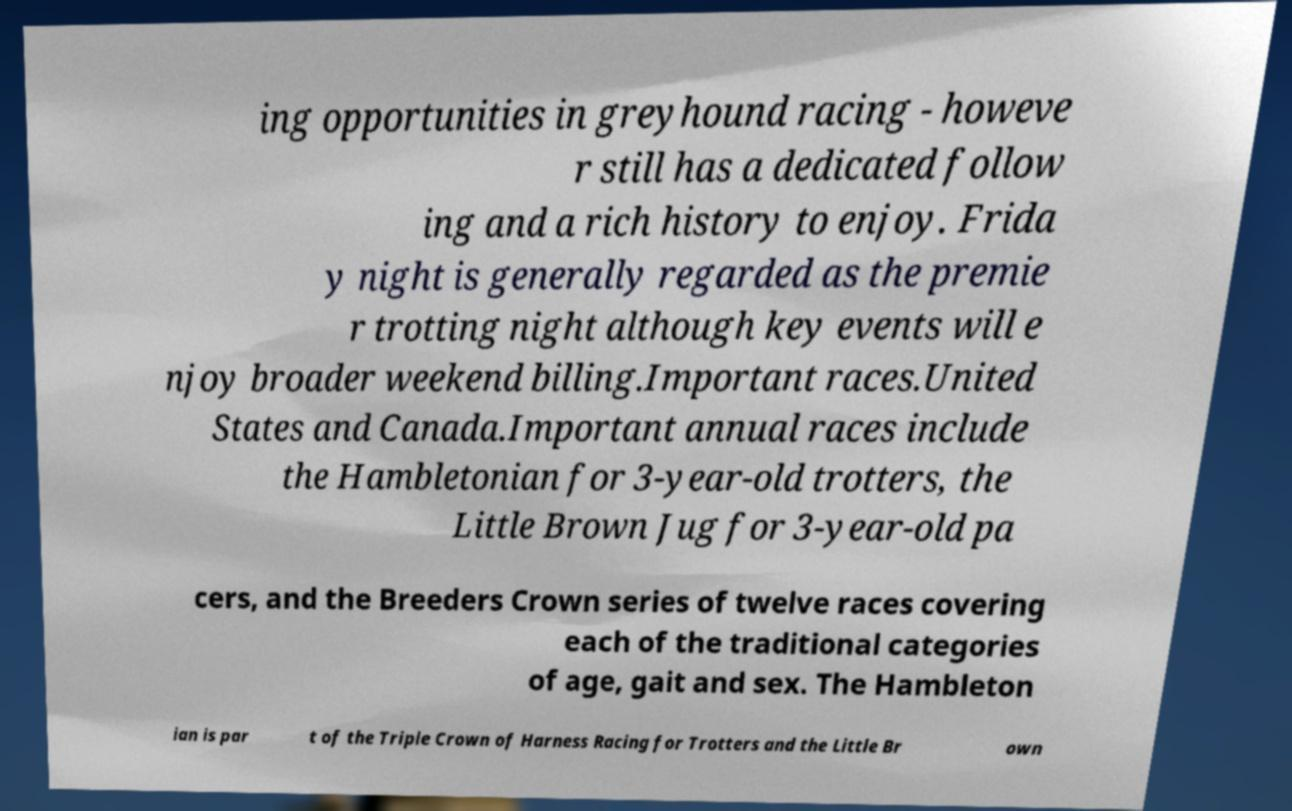For documentation purposes, I need the text within this image transcribed. Could you provide that? ing opportunities in greyhound racing - howeve r still has a dedicated follow ing and a rich history to enjoy. Frida y night is generally regarded as the premie r trotting night although key events will e njoy broader weekend billing.Important races.United States and Canada.Important annual races include the Hambletonian for 3-year-old trotters, the Little Brown Jug for 3-year-old pa cers, and the Breeders Crown series of twelve races covering each of the traditional categories of age, gait and sex. The Hambleton ian is par t of the Triple Crown of Harness Racing for Trotters and the Little Br own 